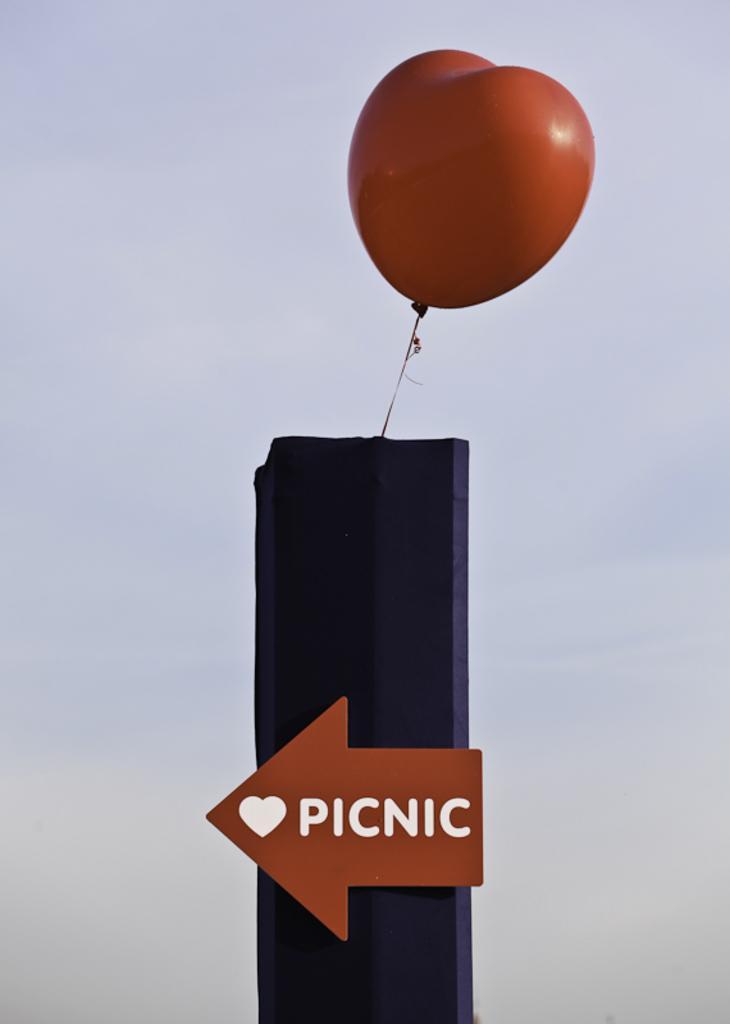Describe this image in one or two sentences. This image consists of a balloon at the top. There is the sky in this image. At the bottom there is ¨picnic¨ written. 